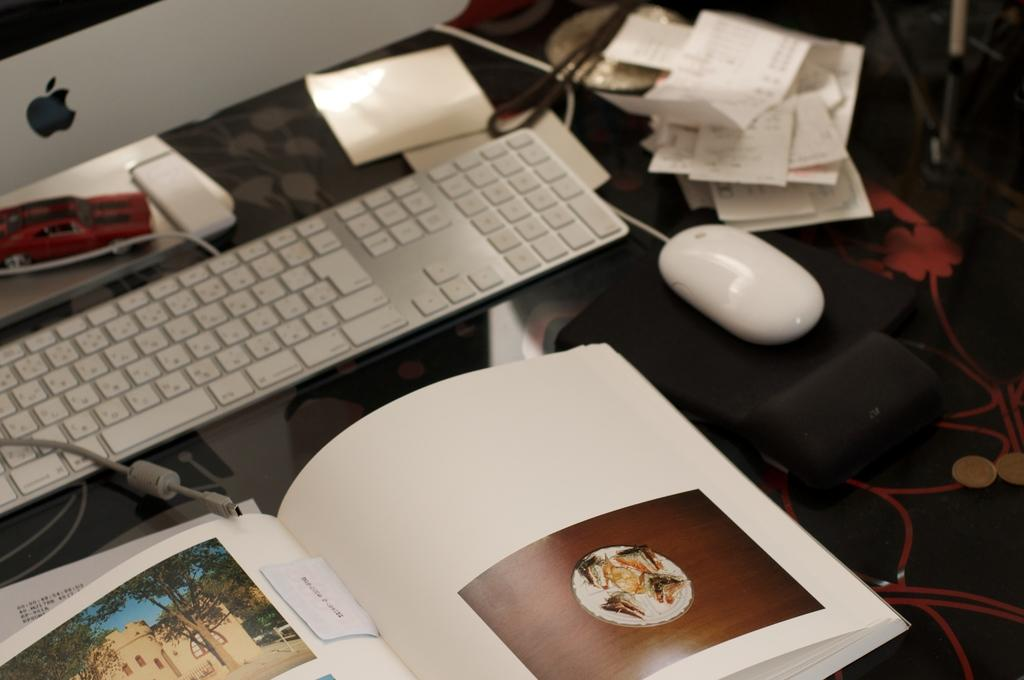What electronic device is present in the image? There is a monitor in the image. What is used for input with the monitor? There is a keyboard in the image. What reading material is visible in the image? There is a book in the image. What type of stationery items can be seen in the image? There are papers in the image. What device is used for controlling the cursor on the monitor? There is a mouse in the image. What small, round objects are present in the image? There are coins in the image. What type of toy is visible in the image? There is a toy car in the image. What color is the paint on the hill in the image? There is no hill or paint present in the image. 